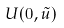<formula> <loc_0><loc_0><loc_500><loc_500>U ( 0 , \tilde { u } )</formula> 